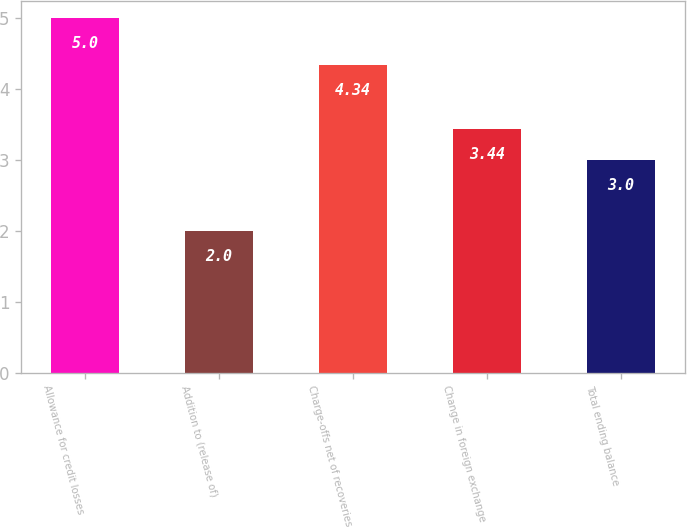<chart> <loc_0><loc_0><loc_500><loc_500><bar_chart><fcel>Allowance for credit losses<fcel>Addition to (release of)<fcel>Charge-offs net of recoveries<fcel>Change in foreign exchange<fcel>Total ending balance<nl><fcel>5<fcel>2<fcel>4.34<fcel>3.44<fcel>3<nl></chart> 